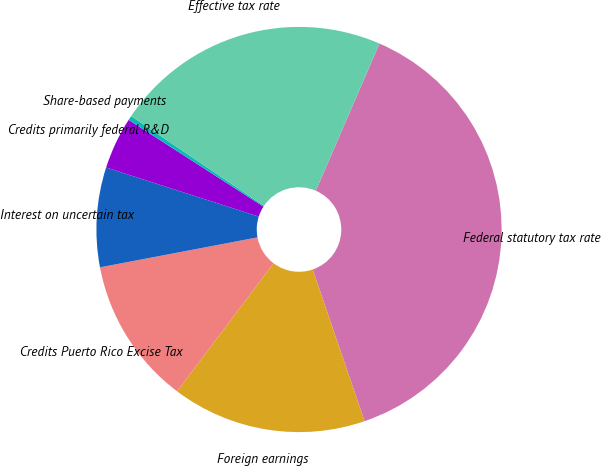<chart> <loc_0><loc_0><loc_500><loc_500><pie_chart><fcel>Federal statutory tax rate<fcel>Foreign earnings<fcel>Credits Puerto Rico Excise Tax<fcel>Interest on uncertain tax<fcel>Credits primarily federal R&D<fcel>Share-based payments<fcel>Effective tax rate<nl><fcel>38.25%<fcel>15.52%<fcel>11.73%<fcel>7.94%<fcel>4.15%<fcel>0.36%<fcel>22.04%<nl></chart> 